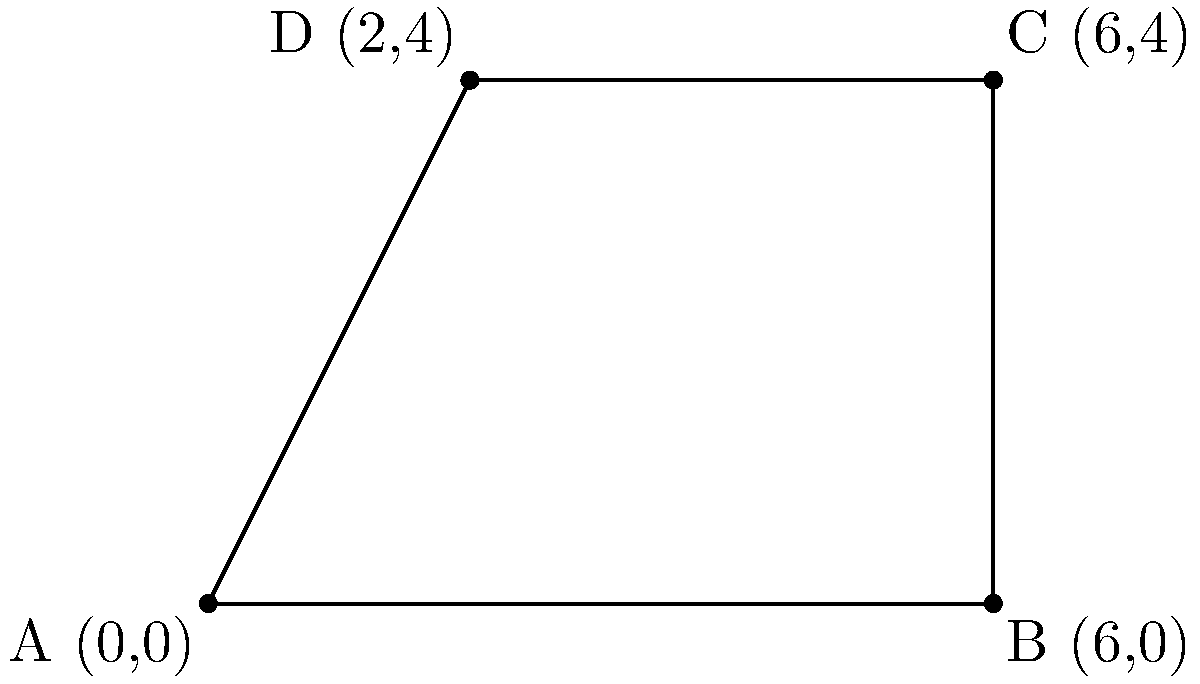A community garden plot is represented as a polygon on a coordinate plane, as shown in the figure above. Calculate the area of this garden plot in square units. To calculate the area of this polygon, we can use the following steps:

1) The polygon can be divided into a rectangle and a triangle.

2) For the rectangle:
   - Width = 2 units (from x=0 to x=2)
   - Height = 4 units (from y=0 to y=4)
   - Area of rectangle = $2 \times 4 = 8$ square units

3) For the triangle:
   - Base = 4 units (from x=2 to x=6)
   - Height = 4 units (same as the rectangle)
   - Area of triangle = $\frac{1}{2} \times 4 \times 4 = 8$ square units

4) Total area:
   - Area = Area of rectangle + Area of triangle
   - Area = $8 + 8 = 16$ square units

Therefore, the total area of the community garden plot is 16 square units.
Answer: 16 square units 